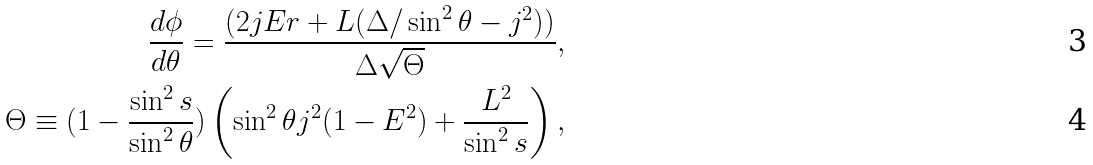<formula> <loc_0><loc_0><loc_500><loc_500>\frac { d \phi } { d \theta } = \frac { ( 2 j E r + L ( \Delta / \sin ^ { 2 } { \theta } - j ^ { 2 } ) ) } { \Delta \sqrt { \Theta } } , \\ \Theta \equiv ( 1 - \frac { \sin ^ { 2 } { s } } { \sin ^ { 2 } { \theta } } ) \left ( \sin ^ { 2 } { \theta } j ^ { 2 } ( 1 - E ^ { 2 } ) + \frac { L ^ { 2 } } { \sin ^ { 2 } { s } } \right ) ,</formula> 